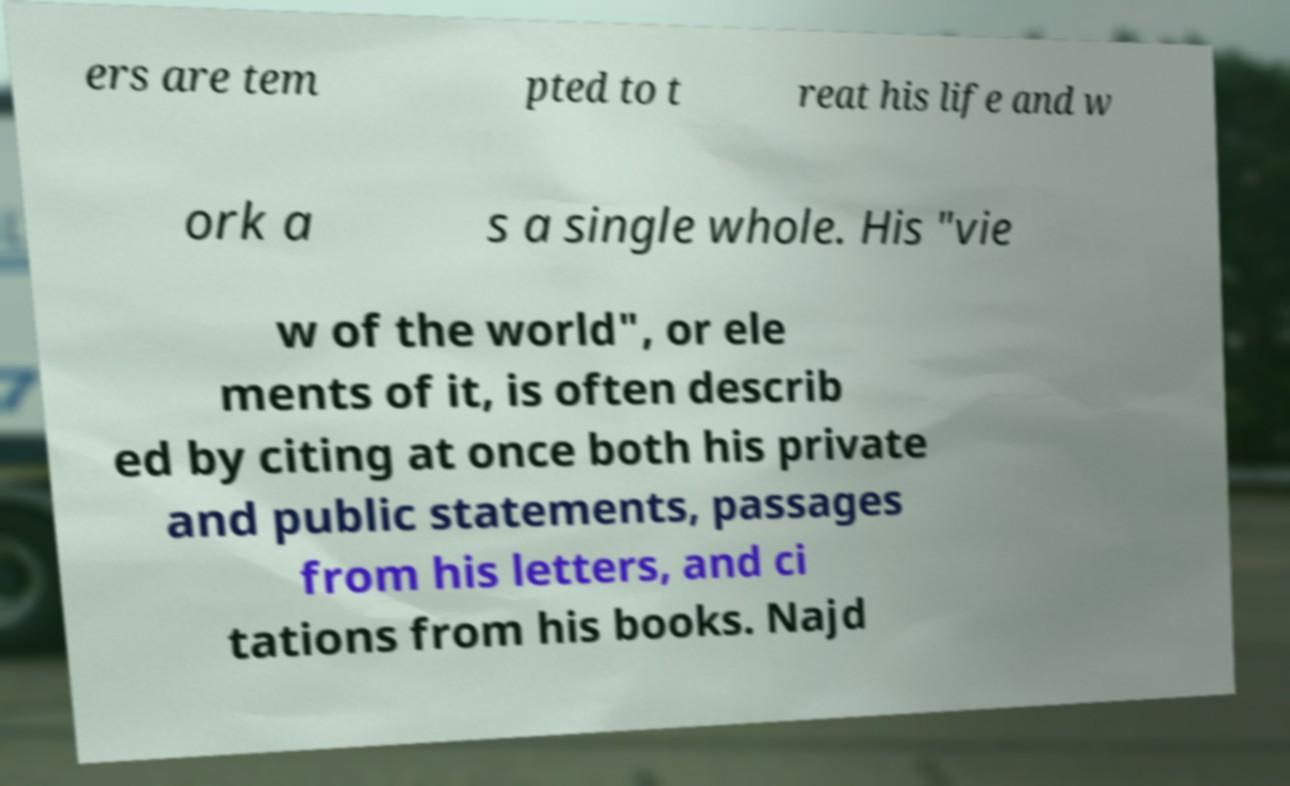There's text embedded in this image that I need extracted. Can you transcribe it verbatim? ers are tem pted to t reat his life and w ork a s a single whole. His "vie w of the world", or ele ments of it, is often describ ed by citing at once both his private and public statements, passages from his letters, and ci tations from his books. Najd 